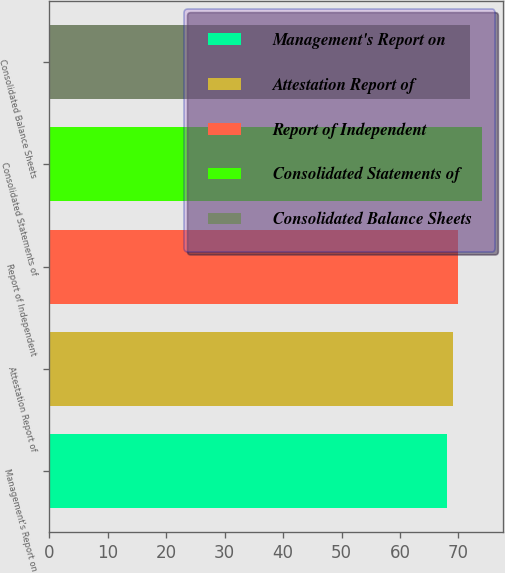Convert chart. <chart><loc_0><loc_0><loc_500><loc_500><bar_chart><fcel>Management's Report on<fcel>Attestation Report of<fcel>Report of Independent<fcel>Consolidated Statements of<fcel>Consolidated Balance Sheets<nl><fcel>68<fcel>69<fcel>70<fcel>74<fcel>72<nl></chart> 